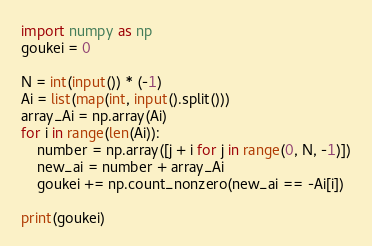Convert code to text. <code><loc_0><loc_0><loc_500><loc_500><_Python_>import numpy as np
goukei = 0

N = int(input()) * (-1)
Ai = list(map(int, input().split()))
array_Ai = np.array(Ai)
for i in range(len(Ai)):
    number = np.array([j + i for j in range(0, N, -1)])
    new_ai = number + array_Ai
    goukei += np.count_nonzero(new_ai == -Ai[i])

print(goukei)</code> 